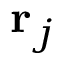<formula> <loc_0><loc_0><loc_500><loc_500>r _ { j }</formula> 